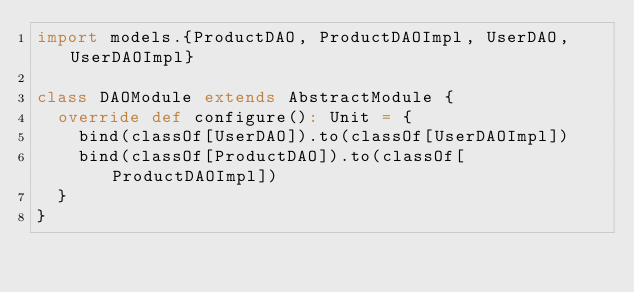<code> <loc_0><loc_0><loc_500><loc_500><_Scala_>import models.{ProductDAO, ProductDAOImpl, UserDAO, UserDAOImpl}

class DAOModule extends AbstractModule {
  override def configure(): Unit = {
    bind(classOf[UserDAO]).to(classOf[UserDAOImpl])
    bind(classOf[ProductDAO]).to(classOf[ProductDAOImpl])
  }
}
</code> 